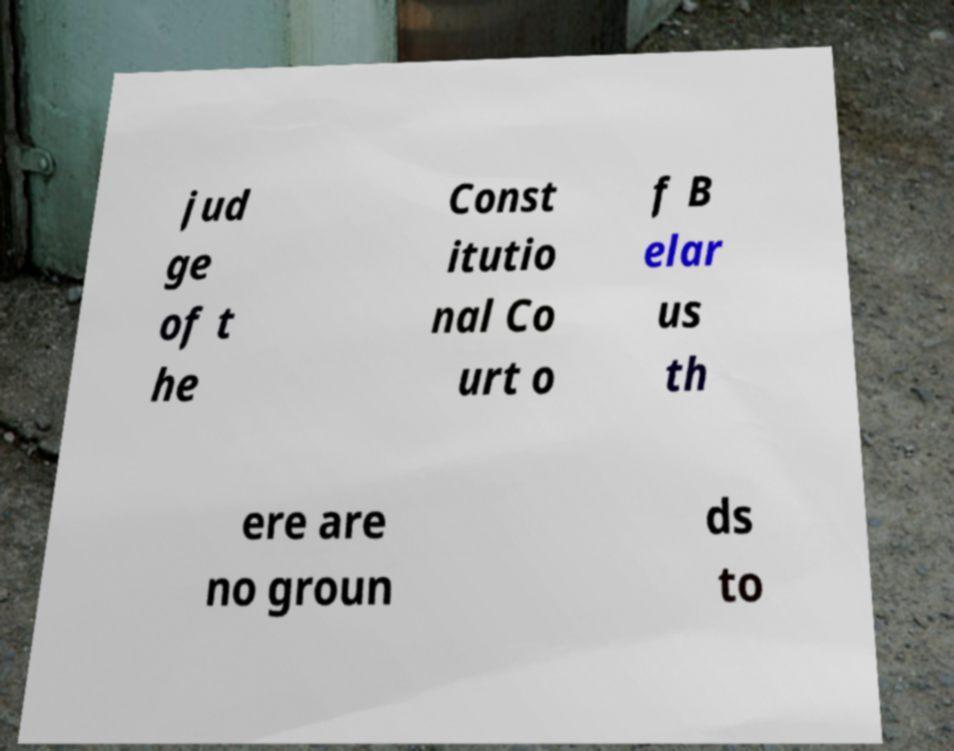Can you accurately transcribe the text from the provided image for me? jud ge of t he Const itutio nal Co urt o f B elar us th ere are no groun ds to 